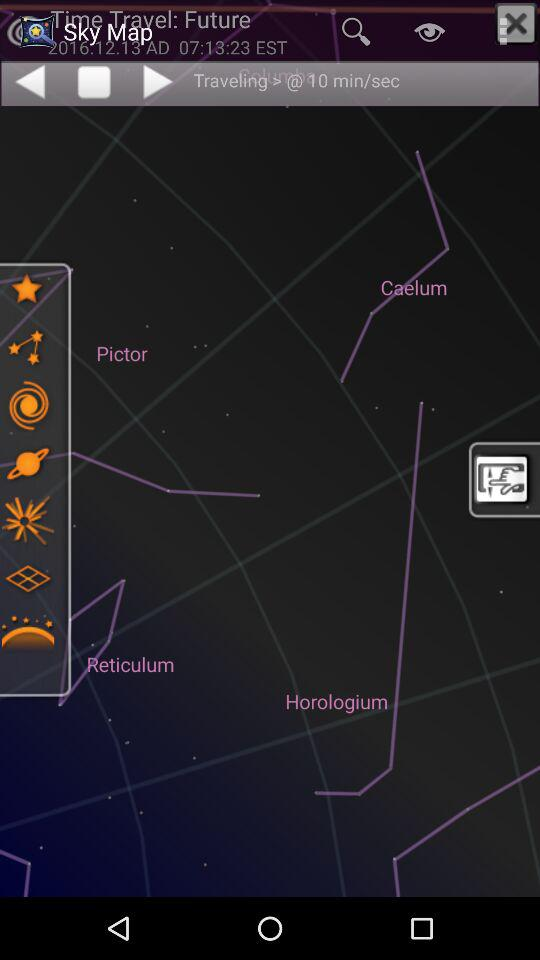What is the time? The time is 07:13:23. 